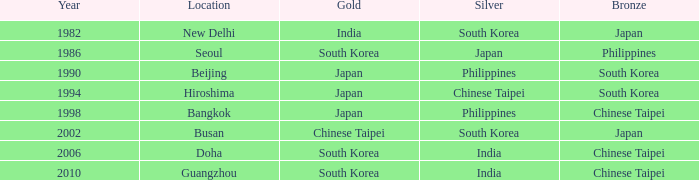Which bronze has a year lesser than 1994, and a silver associated with south korea? Japan. 